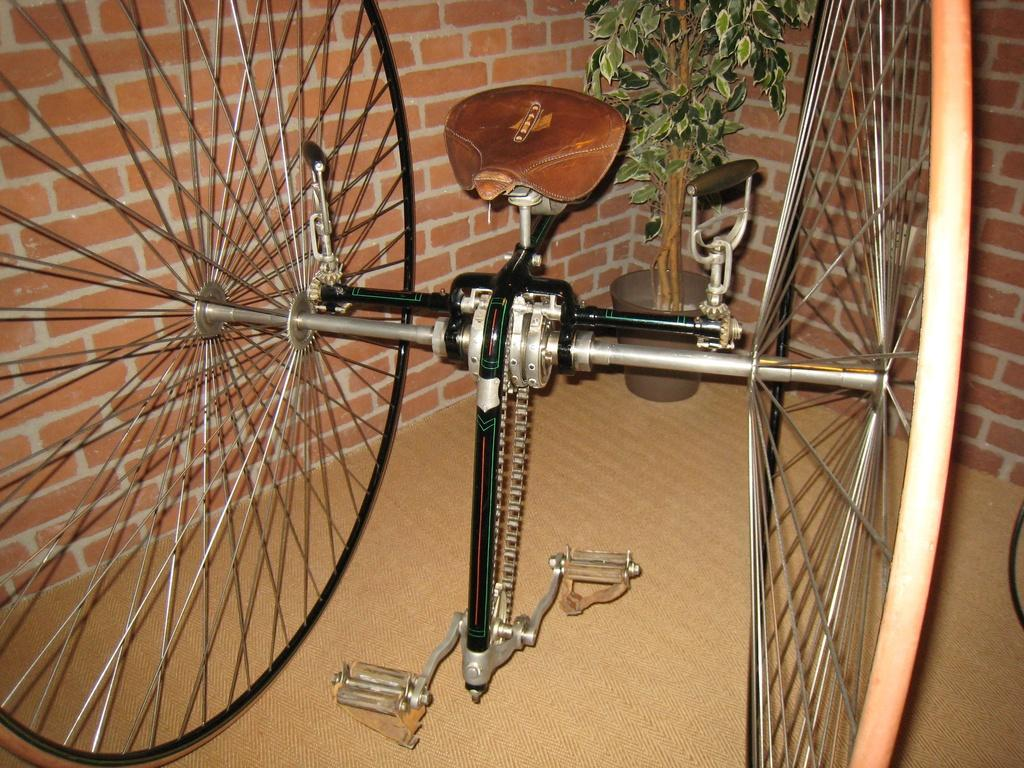What is the main subject of the image? There is a vehicle in the image. How is the vehicle positioned in the image? The vehicle is placed on the ground. What can be seen in the background of the image? There is a plant in a pot and a wall visible in the background of the image. How does the stranger express their disgust while sleeping in the image? There is no stranger, disgust, or sleep depicted in the image; it only features a vehicle, a plant in a pot, and a wall in the background. 